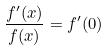<formula> <loc_0><loc_0><loc_500><loc_500>\frac { f ^ { \prime } ( x ) } { f ( x ) } = f ^ { \prime } ( 0 )</formula> 